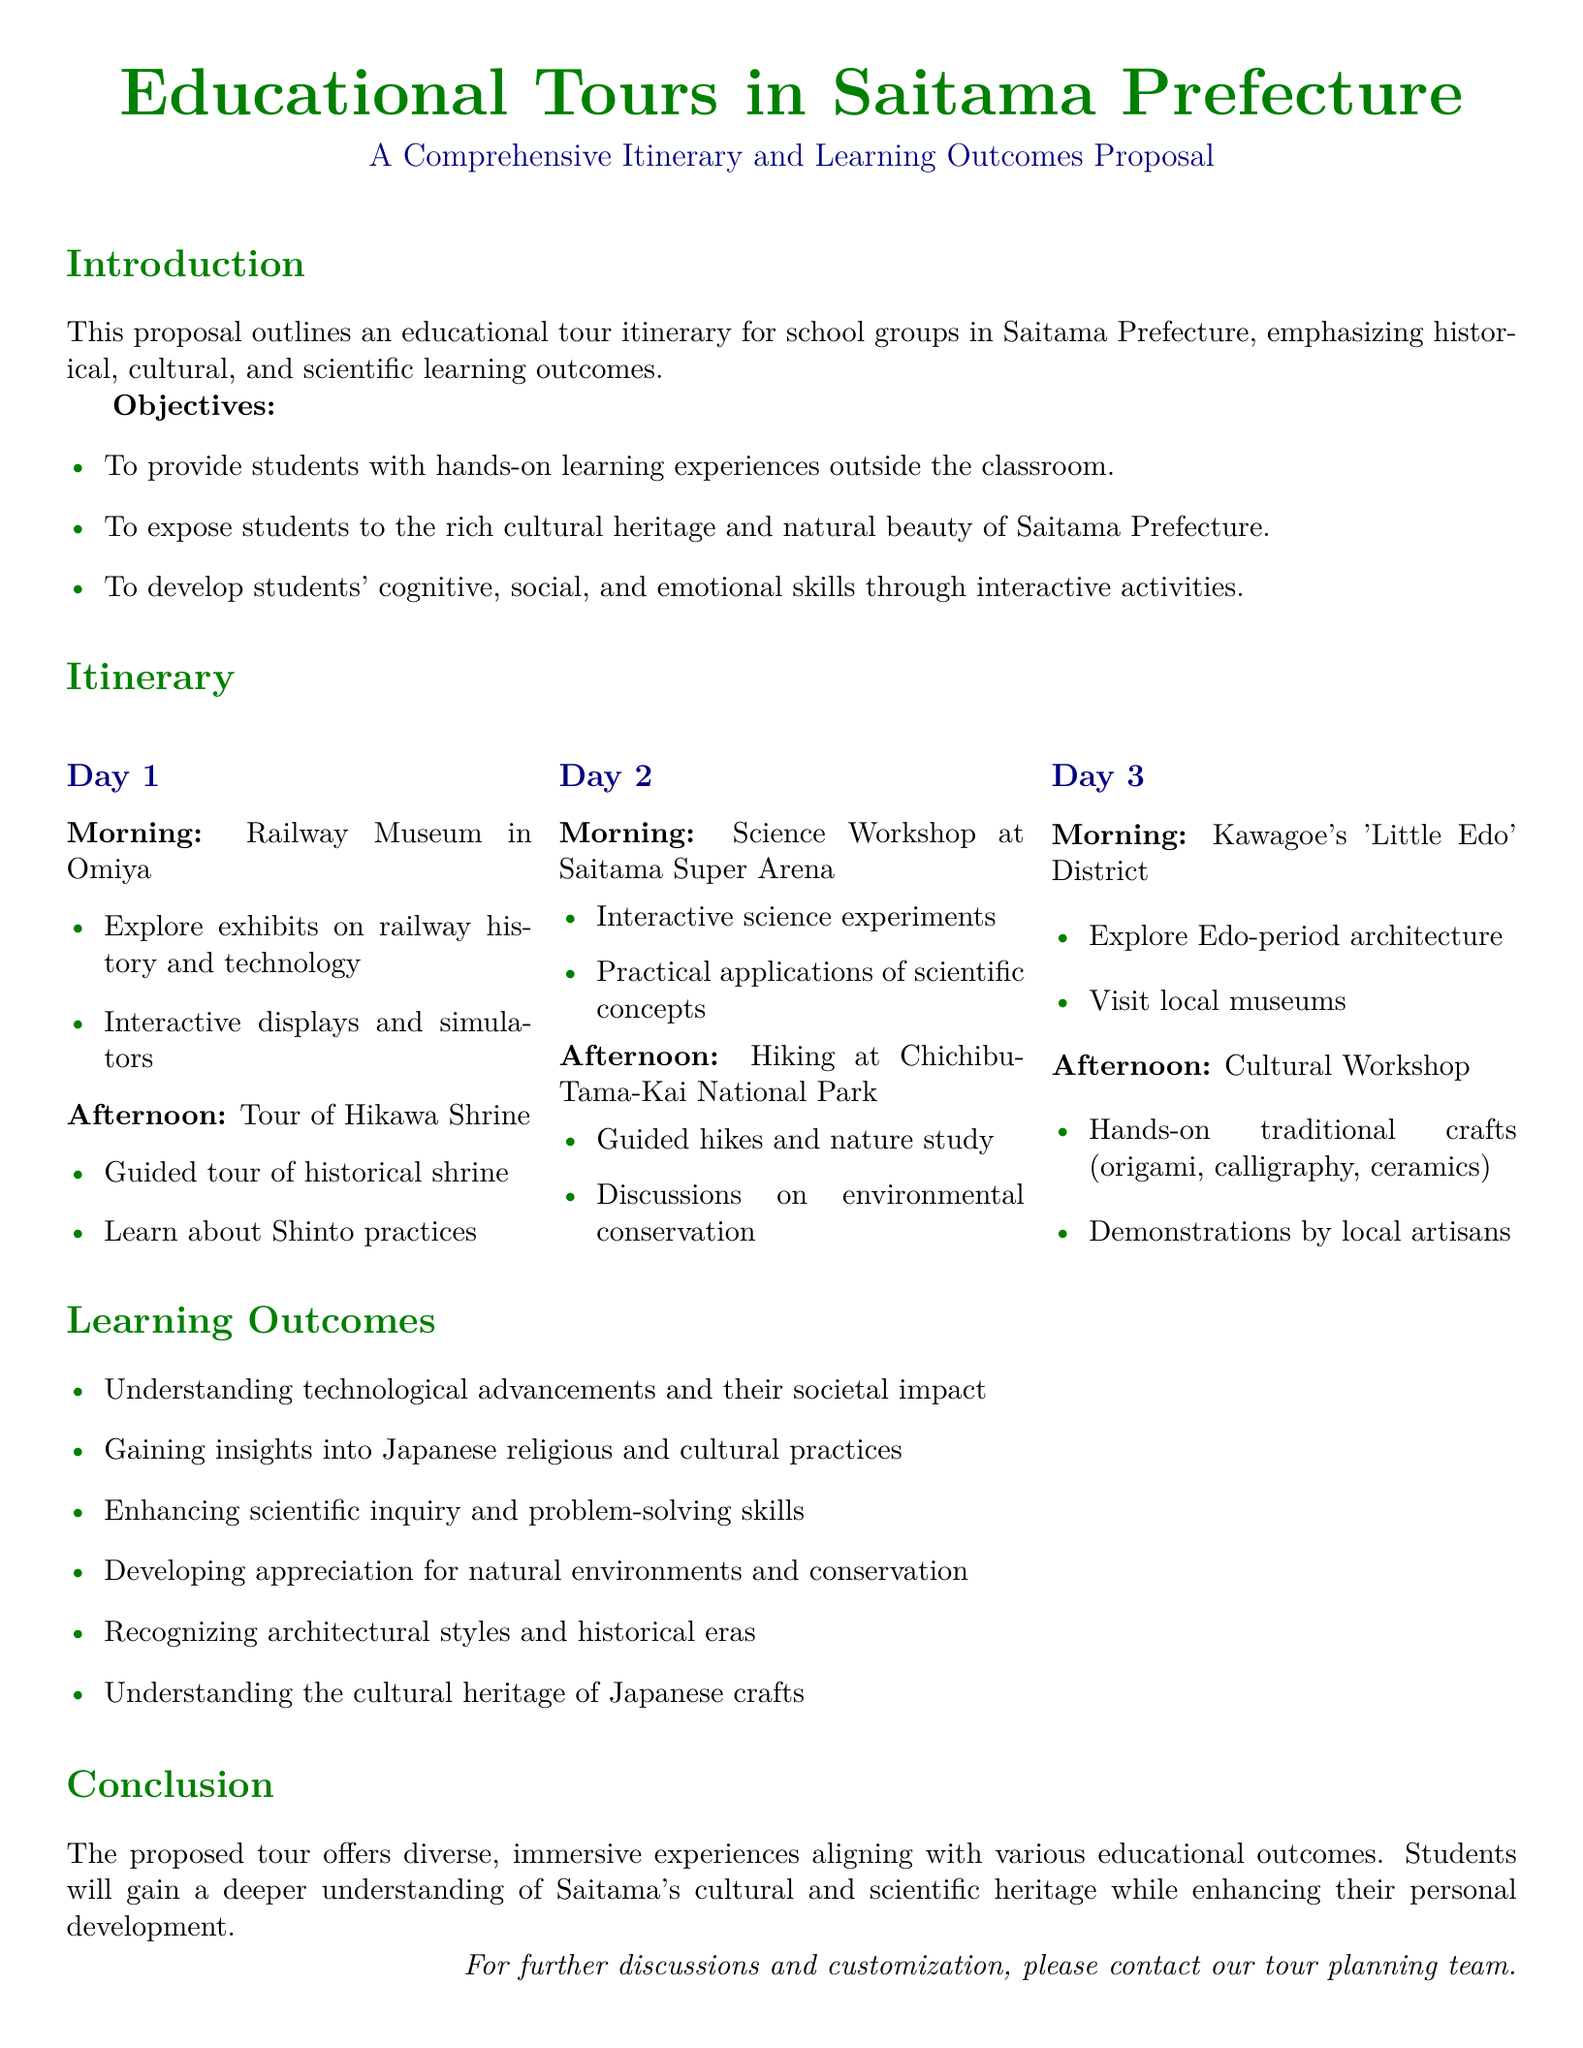What is the main focus of the proposal? The main focus is to outline an educational tour itinerary for school groups in Saitama Prefecture.
Answer: Educational tour itinerary What is the name of the museum visited on Day 1? The museum visited on Day 1 is mentioned as a specific name in the itinerary.
Answer: Railway Museum How many days does the itinerary cover? The number of days specified in the itinerary represents the structure of the proposal.
Answer: Three days What is one of the objectives of the educational tours? The objectives are listed to highlight the purpose of the tours for school groups.
Answer: Hands-on learning experiences Which national park is included in the itinerary? The specific national park mentioned in the itinerary identifies a key location for the activities.
Answer: Chichibu-Tama-Kai National Park What type of workshop is offered in Kawagoe on Day 3? The workshop type is specified in the itinerary to reflect a cultural aspect of the tour.
Answer: Cultural Workshop How does the proposal suggest enhancing students' skills? The document outlines various activities aimed at improving specific student skills during the tours.
Answer: Interactive activities What religious practices are explored at Hikawa Shrine? The specific practices mentioned in the itinerary indicate the educational content of the visit.
Answer: Shinto practices 